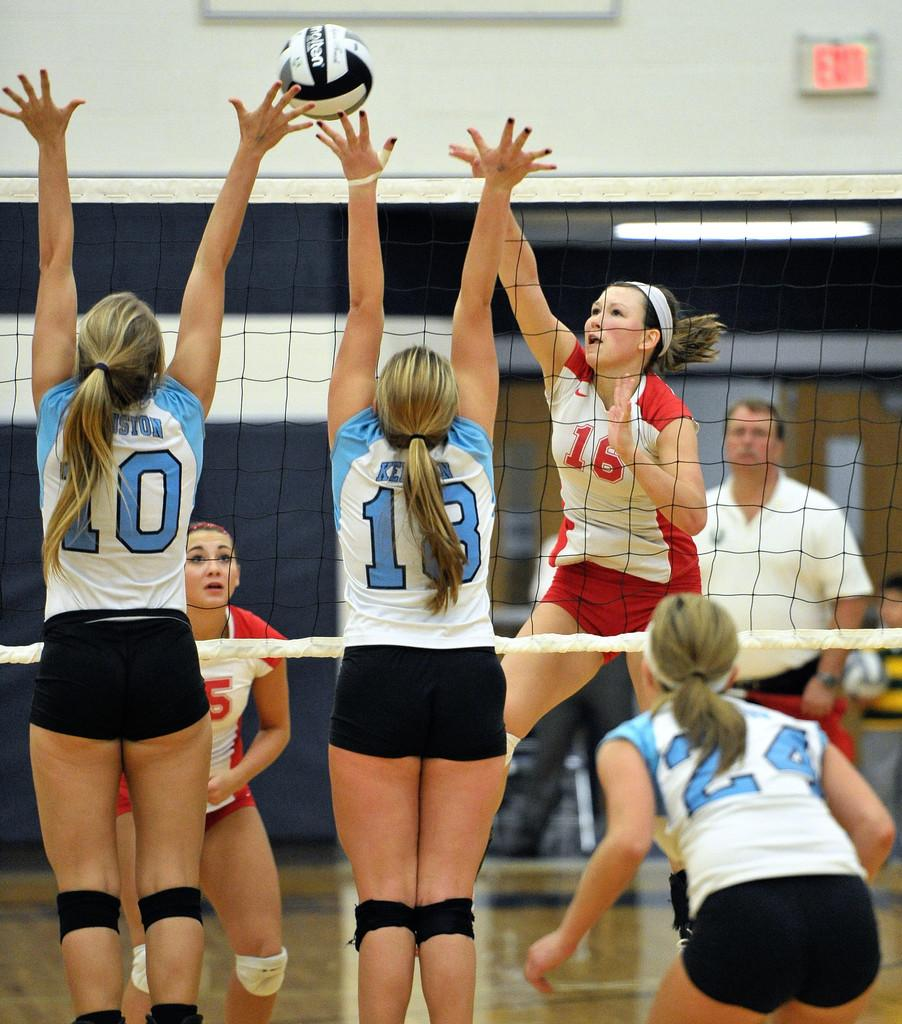<image>
Describe the image concisely. Some girls play volleyball, one has the number 16 on his shirt. 